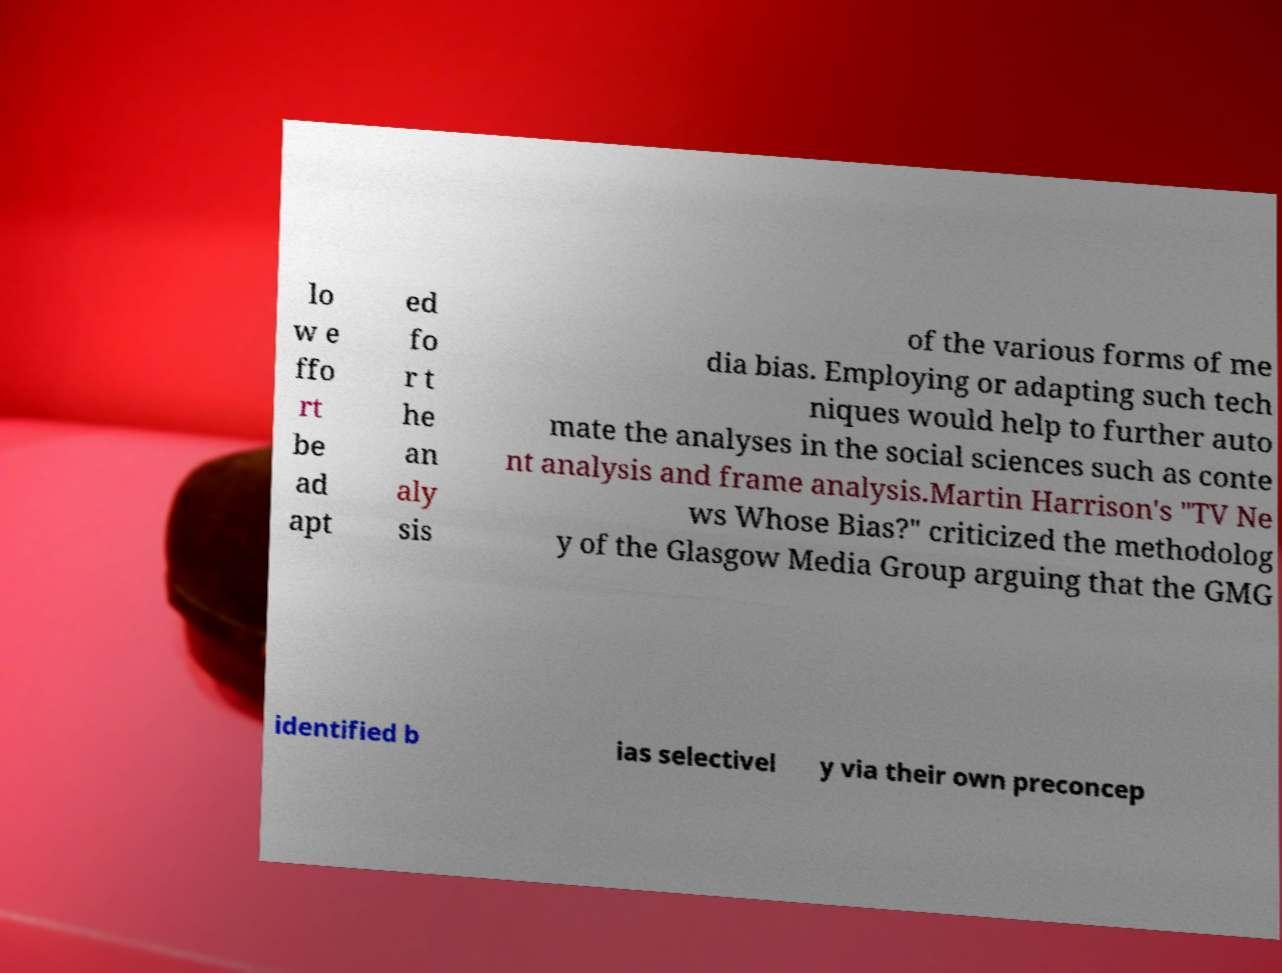There's text embedded in this image that I need extracted. Can you transcribe it verbatim? lo w e ffo rt be ad apt ed fo r t he an aly sis of the various forms of me dia bias. Employing or adapting such tech niques would help to further auto mate the analyses in the social sciences such as conte nt analysis and frame analysis.Martin Harrison's "TV Ne ws Whose Bias?" criticized the methodolog y of the Glasgow Media Group arguing that the GMG identified b ias selectivel y via their own preconcep 